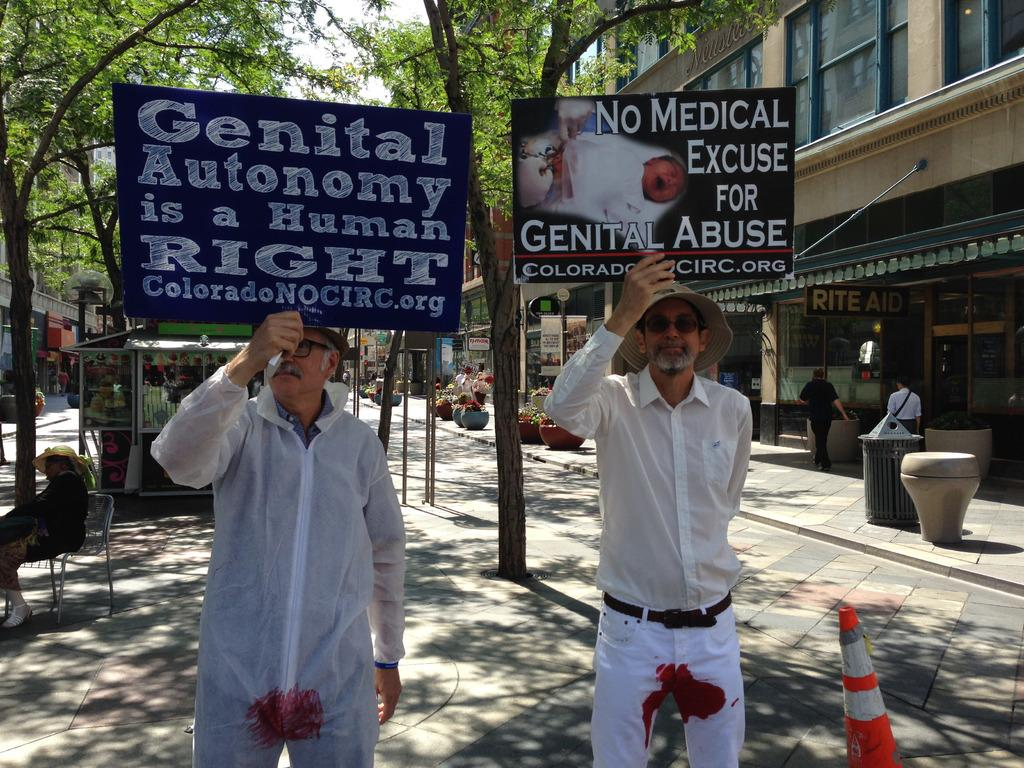What are the persons in the center of the image doing? The persons in the center of the image are standing on the road and holding boards. What can be seen in the background of the image? There are trees, buildings, poles, and persons visible in the background of the image. What is visible in the sky in the background of the image? The sky is visible in the background of the image. Can you see any cracks in the road where the persons are standing? There is no mention of cracks in the road in the image, so we cannot determine if any are present. What type of nail is being used by the dad in the image? There is no dad or nail mentioned in the image, so we cannot answer this question. 